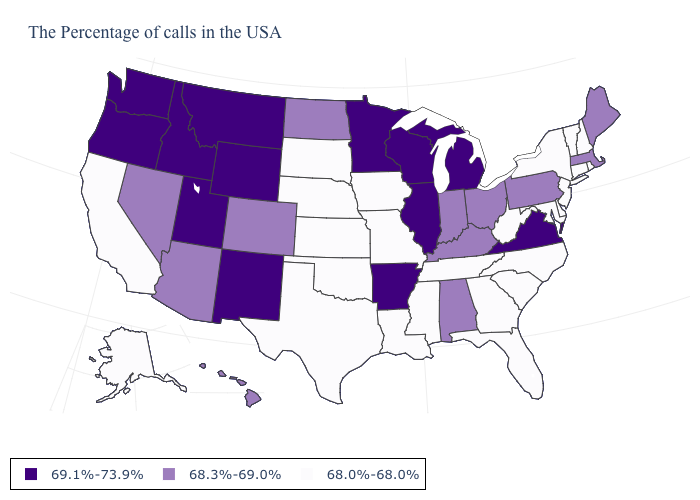What is the value of Oregon?
Quick response, please. 69.1%-73.9%. What is the value of Vermont?
Give a very brief answer. 68.0%-68.0%. What is the value of Massachusetts?
Keep it brief. 68.3%-69.0%. Does Delaware have the same value as Georgia?
Answer briefly. Yes. Which states have the highest value in the USA?
Give a very brief answer. Virginia, Michigan, Wisconsin, Illinois, Arkansas, Minnesota, Wyoming, New Mexico, Utah, Montana, Idaho, Washington, Oregon. Which states have the lowest value in the USA?
Short answer required. Rhode Island, New Hampshire, Vermont, Connecticut, New York, New Jersey, Delaware, Maryland, North Carolina, South Carolina, West Virginia, Florida, Georgia, Tennessee, Mississippi, Louisiana, Missouri, Iowa, Kansas, Nebraska, Oklahoma, Texas, South Dakota, California, Alaska. Is the legend a continuous bar?
Be succinct. No. Does the map have missing data?
Be succinct. No. What is the value of Iowa?
Write a very short answer. 68.0%-68.0%. Does Louisiana have the same value as Oklahoma?
Write a very short answer. Yes. Name the states that have a value in the range 68.3%-69.0%?
Short answer required. Maine, Massachusetts, Pennsylvania, Ohio, Kentucky, Indiana, Alabama, North Dakota, Colorado, Arizona, Nevada, Hawaii. Name the states that have a value in the range 68.3%-69.0%?
Be succinct. Maine, Massachusetts, Pennsylvania, Ohio, Kentucky, Indiana, Alabama, North Dakota, Colorado, Arizona, Nevada, Hawaii. Which states hav the highest value in the Northeast?
Concise answer only. Maine, Massachusetts, Pennsylvania. What is the value of Missouri?
Concise answer only. 68.0%-68.0%. What is the value of Hawaii?
Answer briefly. 68.3%-69.0%. 